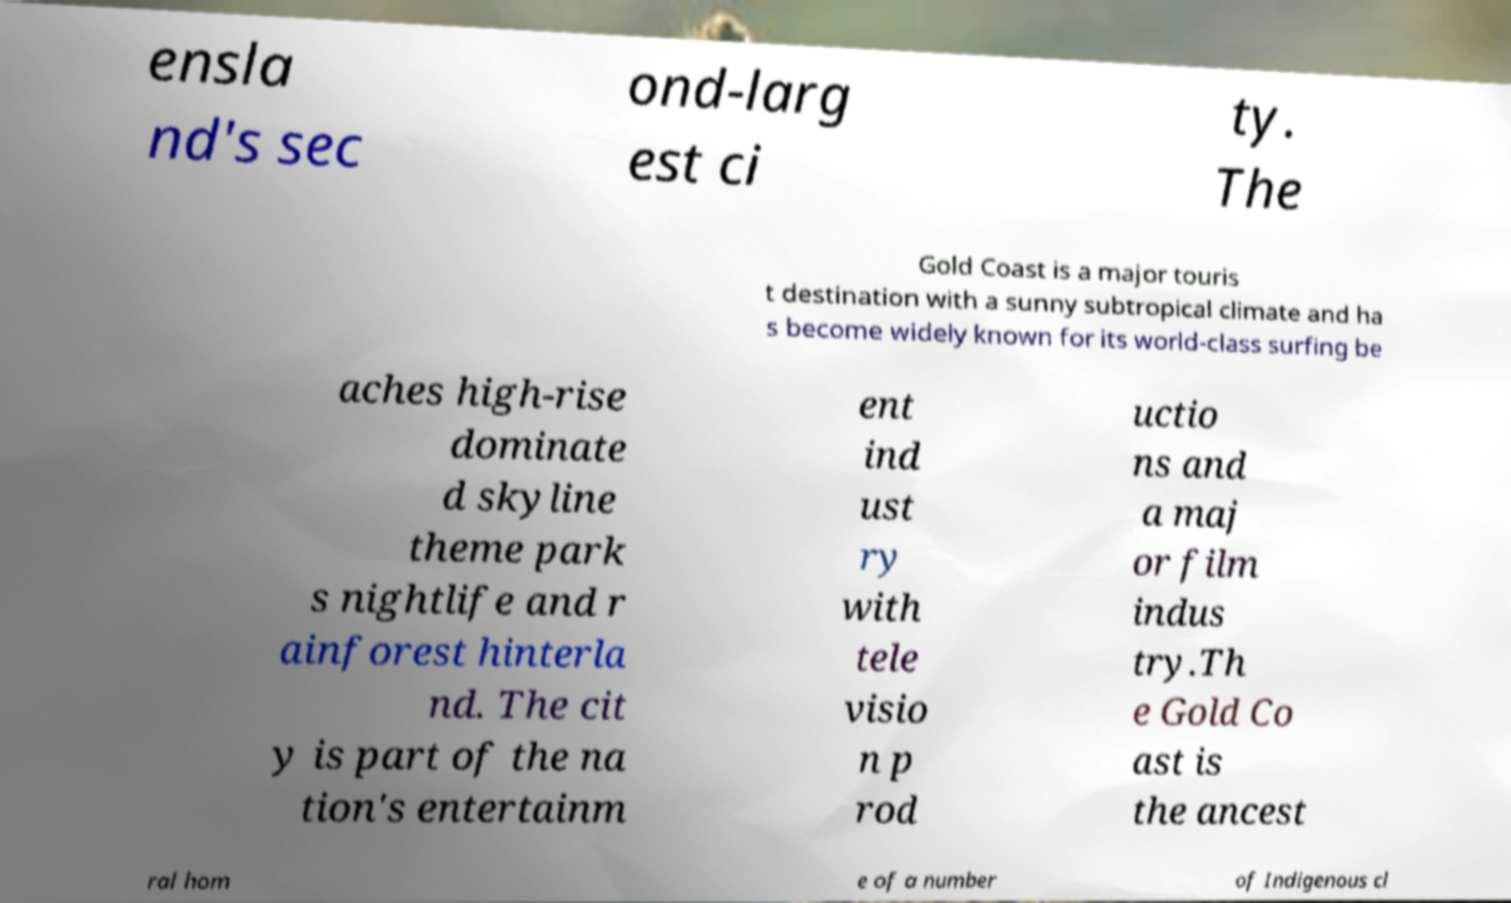There's text embedded in this image that I need extracted. Can you transcribe it verbatim? ensla nd's sec ond-larg est ci ty. The Gold Coast is a major touris t destination with a sunny subtropical climate and ha s become widely known for its world-class surfing be aches high-rise dominate d skyline theme park s nightlife and r ainforest hinterla nd. The cit y is part of the na tion's entertainm ent ind ust ry with tele visio n p rod uctio ns and a maj or film indus try.Th e Gold Co ast is the ancest ral hom e of a number of Indigenous cl 